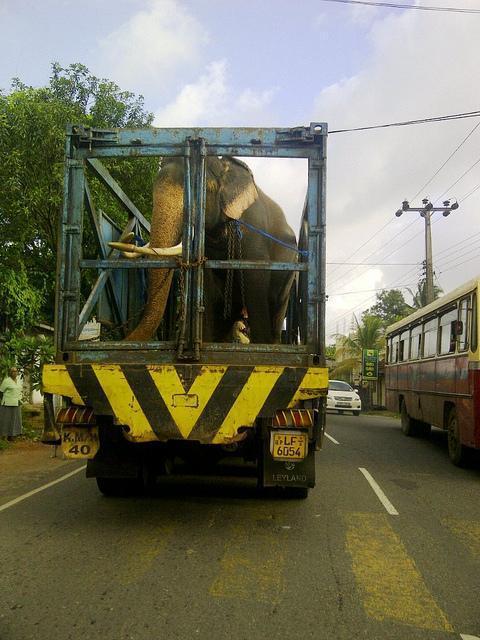Is this affirmation: "The truck is behind the bus." correct?
Answer yes or no. No. Does the image validate the caption "The truck contains the elephant."?
Answer yes or no. Yes. 